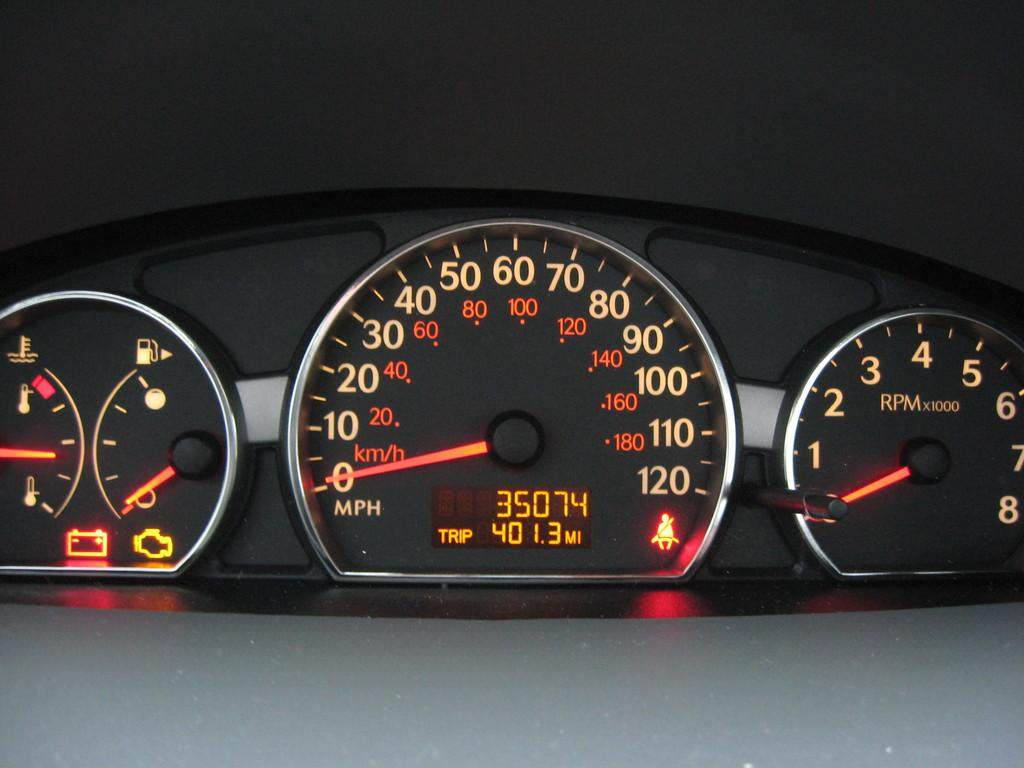What type of meters are visible in the image? There are analogue meters in the image. How many lizards can be seen hiding behind the analogue meters in the image? There are no lizards present in the image; it only features analogue meters. 